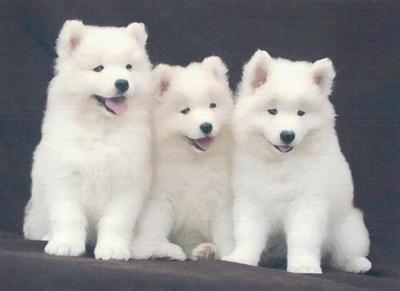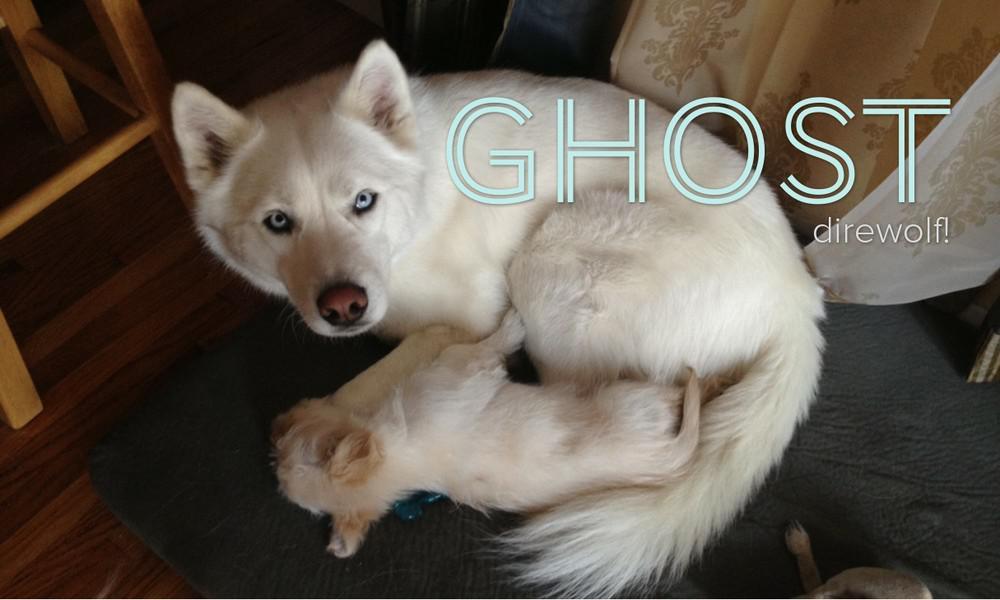The first image is the image on the left, the second image is the image on the right. For the images shown, is this caption "One dog is outdoors, and one dog is indoors." true? Answer yes or no. No. The first image is the image on the left, the second image is the image on the right. Analyze the images presented: Is the assertion "An image shows one white dog wearing something other than a dog collar." valid? Answer yes or no. No. 